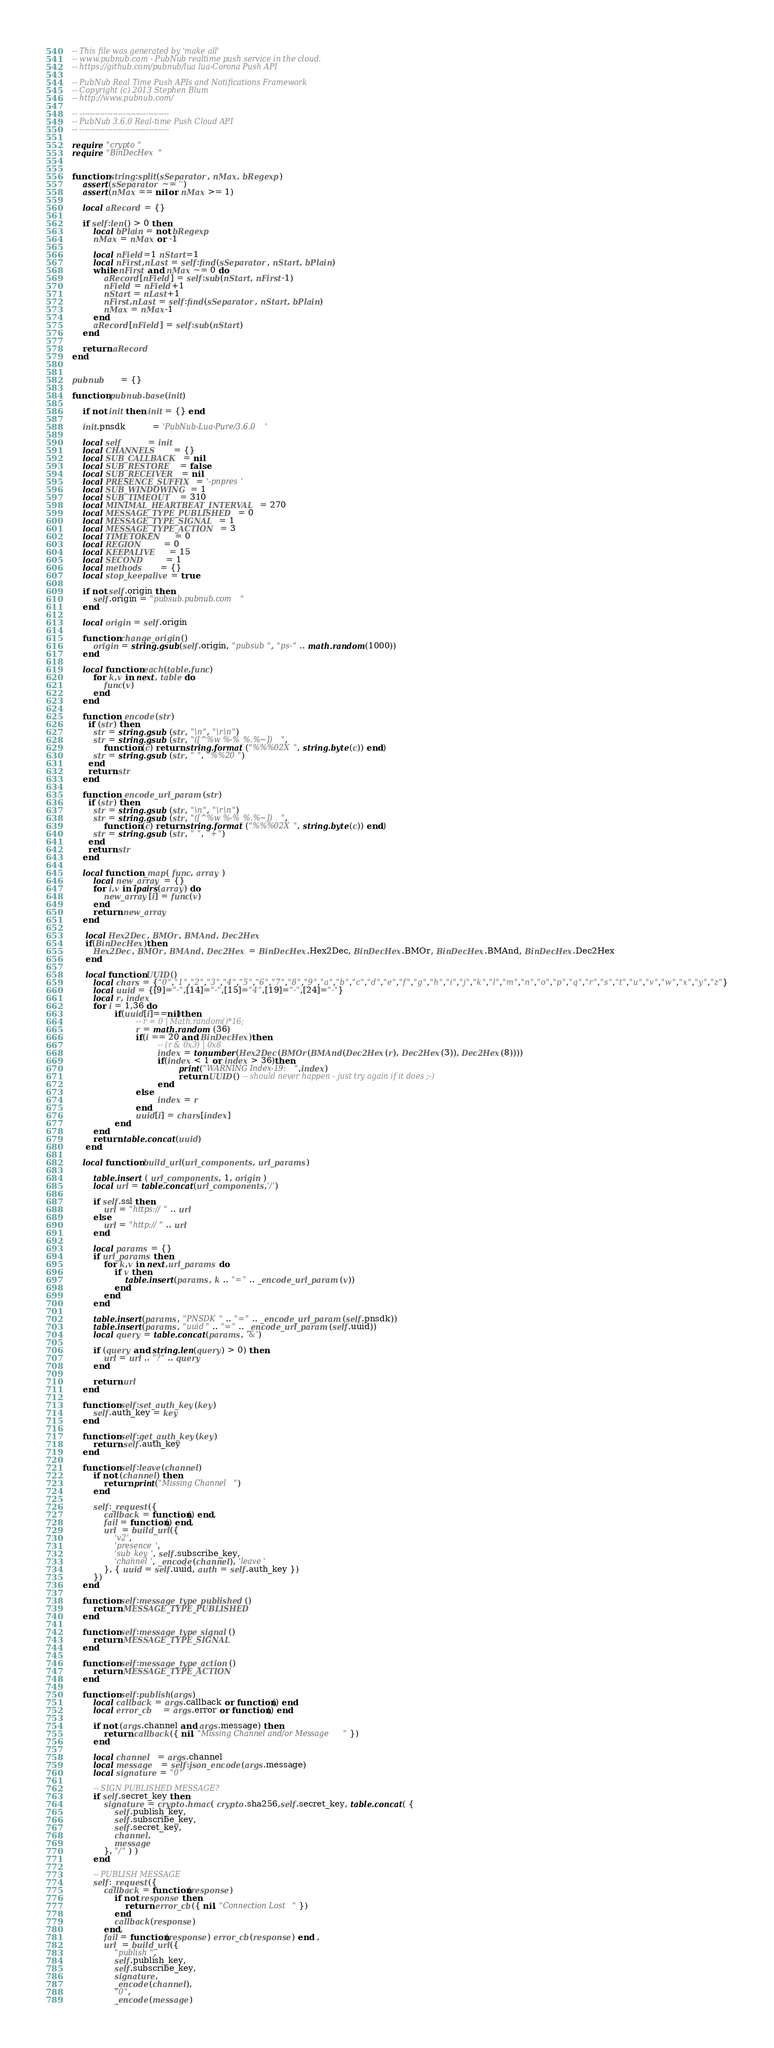Convert code to text. <code><loc_0><loc_0><loc_500><loc_500><_Lua_>-- This file was generated by 'make all'
-- www.pubnub.com - PubNub realtime push service in the cloud.
-- https://github.com/pubnub/lua lua-Corona Push API

-- PubNub Real Time Push APIs and Notifications Framework
-- Copyright (c) 2013 Stephen Blum
-- http://www.pubnub.com/

-- -----------------------------------
-- PubNub 3.6.0 Real-time Push Cloud API
-- -----------------------------------

require "crypto"
require "BinDecHex"


function string:split(sSeparator, nMax, bRegexp)
    assert(sSeparator ~= '')
    assert(nMax == nil or nMax >= 1)

    local aRecord = {}

    if self:len() > 0 then
        local bPlain = not bRegexp
        nMax = nMax or -1

        local nField=1 nStart=1
        local nFirst,nLast = self:find(sSeparator, nStart, bPlain)
        while nFirst and nMax ~= 0 do
            aRecord[nField] = self:sub(nStart, nFirst-1)
            nField = nField+1
            nStart = nLast+1
            nFirst,nLast = self:find(sSeparator, nStart, bPlain)
            nMax = nMax-1
        end
        aRecord[nField] = self:sub(nStart)
    end

    return aRecord
end


pubnub      = {}

function pubnub.base(init)

    if not init then init = {} end

    init.pnsdk          = 'PubNub-Lua-Pure/3.6.0'

    local self          = init
    local CHANNELS      = {}
    local SUB_CALLBACK  = nil
    local SUB_RESTORE   = false
    local SUB_RECEIVER  = nil
    local PRESENCE_SUFFIX = '-pnpres'
    local SUB_WINDOWING = 1
    local SUB_TIMEOUT   = 310
    local MINIMAL_HEARTBEAT_INTERVAL = 270
    local MESSAGE_TYPE_PUBLISHED = 0
    local MESSAGE_TYPE_SIGNAL = 1
    local MESSAGE_TYPE_ACTION = 3
    local TIMETOKEN     = 0
    local REGION        = 0
    local KEEPALIVE     = 15
    local SECOND        = 1
    local methods       = {}
    local stop_keepalive = true

    if not self.origin then
        self.origin = "pubsub.pubnub.com"
    end

    local origin = self.origin

    function change_origin()
        origin = string.gsub(self.origin, "pubsub", "ps-" .. math.random(1000))
    end

    local function each(table,func)
        for k,v in next, table do
            func(v)
        end
    end

    function _encode(str)
      if (str) then
        str = string.gsub (str, "\n", "\r\n")
        str = string.gsub (str, "([^%w %-%_%.%~])",
            function (c) return string.format ("%%%02X", string.byte(c)) end)
        str = string.gsub (str, " ", "%%20")
      end
      return str
    end

    function _encode_url_param(str)
      if (str) then
        str = string.gsub (str, "\n", "\r\n")
        str = string.gsub (str, "([^%w %-%_%.%~])",
            function (c) return string.format ("%%%02X", string.byte(c)) end)
        str = string.gsub (str, " ", "+")
      end
      return str
    end

    local function _map( func, array )
        local new_array = {}
        for i,v in ipairs(array) do
            new_array[i] = func(v)
        end
        return new_array
    end

     local Hex2Dec, BMOr, BMAnd, Dec2Hex
     if(BinDecHex)then
        Hex2Dec, BMOr, BMAnd, Dec2Hex = BinDecHex.Hex2Dec, BinDecHex.BMOr, BinDecHex.BMAnd, BinDecHex.Dec2Hex
     end

     local function UUID()
        local chars = {"0","1","2","3","4","5","6","7","8","9","a","b","c","d","e","f","g","h","i","j","k","l","m","n","o","p","q","r","s","t","u","v","w","x","y","z"}
        local uuid = {[9]="-",[14]="-",[15]="4",[19]="-",[24]="-"}
        local r, index
        for i = 1,36 do
                if(uuid[i]==nil)then
                        -- r = 0 | Math.random()*16;
                        r = math.random (36)
                        if(i == 20 and BinDecHex)then
                                -- (r & 0x3) | 0x8
                                index = tonumber(Hex2Dec(BMOr(BMAnd(Dec2Hex(r), Dec2Hex(3)), Dec2Hex(8))))
                                if(index < 1 or index > 36)then
                                        print("WARNING Index-19:",index)
                                        return UUID() -- should never happen - just try again if it does ;-)
                                end
                        else
                                index = r
                        end
                        uuid[i] = chars[index]
                end
        end
        return table.concat(uuid)
     end

    local function build_url(url_components, url_params)

        table.insert ( url_components, 1, origin )
        local url = table.concat(url_components,'/')

        if self.ssl then
            url = "https://" .. url
        else
            url = "http://" .. url
        end

        local params = {}
        if url_params then
            for k,v in next,url_params do
                if v then
                    table.insert(params, k .. "=" .. _encode_url_param(v))
                end
            end
        end

        table.insert(params, "PNSDK" .. "=" .. _encode_url_param(self.pnsdk))
        table.insert(params, "uuid" .. "=" .. _encode_url_param(self.uuid))
        local query = table.concat(params, '&')

        if (query and string.len(query) > 0) then
            url = url .. "?" .. query
        end

        return url
    end

    function self:set_auth_key(key)
        self.auth_key = key
    end

    function self:get_auth_key(key)
        return self.auth_key
    end

    function self:leave(channel)
        if not (channel) then
            return print("Missing Channel")
        end

        self:_request({
            callback = function() end,
            fail = function() end,
            url  = build_url({
                'v2',
                'presence',
                'sub_key', self.subscribe_key,
                'channel', _encode(channel), 'leave'
            }, { uuid = self.uuid, auth = self.auth_key })
        })
    end

    function self:message_type_published()
        return MESSAGE_TYPE_PUBLISHED
    end

    function self:message_type_signal()
        return MESSAGE_TYPE_SIGNAL
    end

    function self:message_type_action()
        return MESSAGE_TYPE_ACTION
    end

    function self:publish(args)
        local callback = args.callback or function() end
        local error_cb    = args.error or function() end

        if not (args.channel and args.message) then
            return callback({ nil, "Missing Channel and/or Message" })
        end

        local channel   = args.channel
        local message   = self:json_encode(args.message)
        local signature = "0"

        -- SIGN PUBLISHED MESSAGE?
        if self.secret_key then
            signature = crypto.hmac( crypto.sha256,self.secret_key, table.concat( {
                self.publish_key,
                self.subscribe_key,
                self.secret_key,
                channel,
                message
            }, "/" ) )
        end

        -- PUBLISH MESSAGE
        self:_request({
            callback = function(response)
                if not response then
                    return error_cb({ nil, "Connection Lost" })
                end
                callback(response)
            end,
            fail = function(response) error_cb(response) end ,
            url  = build_url({
                "publish",
                self.publish_key,
                self.subscribe_key,
                signature,
                _encode(channel),
                "0",
                _encode(message)</code> 